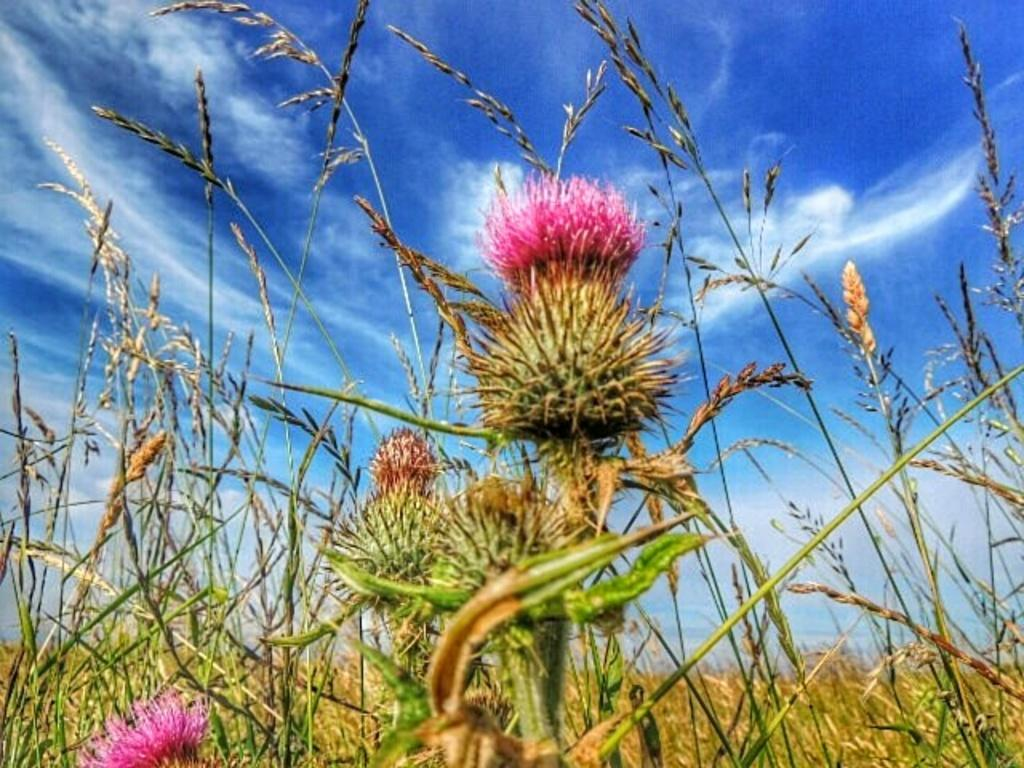What type of plants can be seen in the image? There are plants with flowers in the image. What can be seen in the background of the image? The sky is visible in the background of the image. What is the condition of the sky in the image? Clouds are present in the sky. What rule is being enforced by the plants in the image? There is no rule being enforced by the plants in the image; they are simply growing and displaying flowers. 